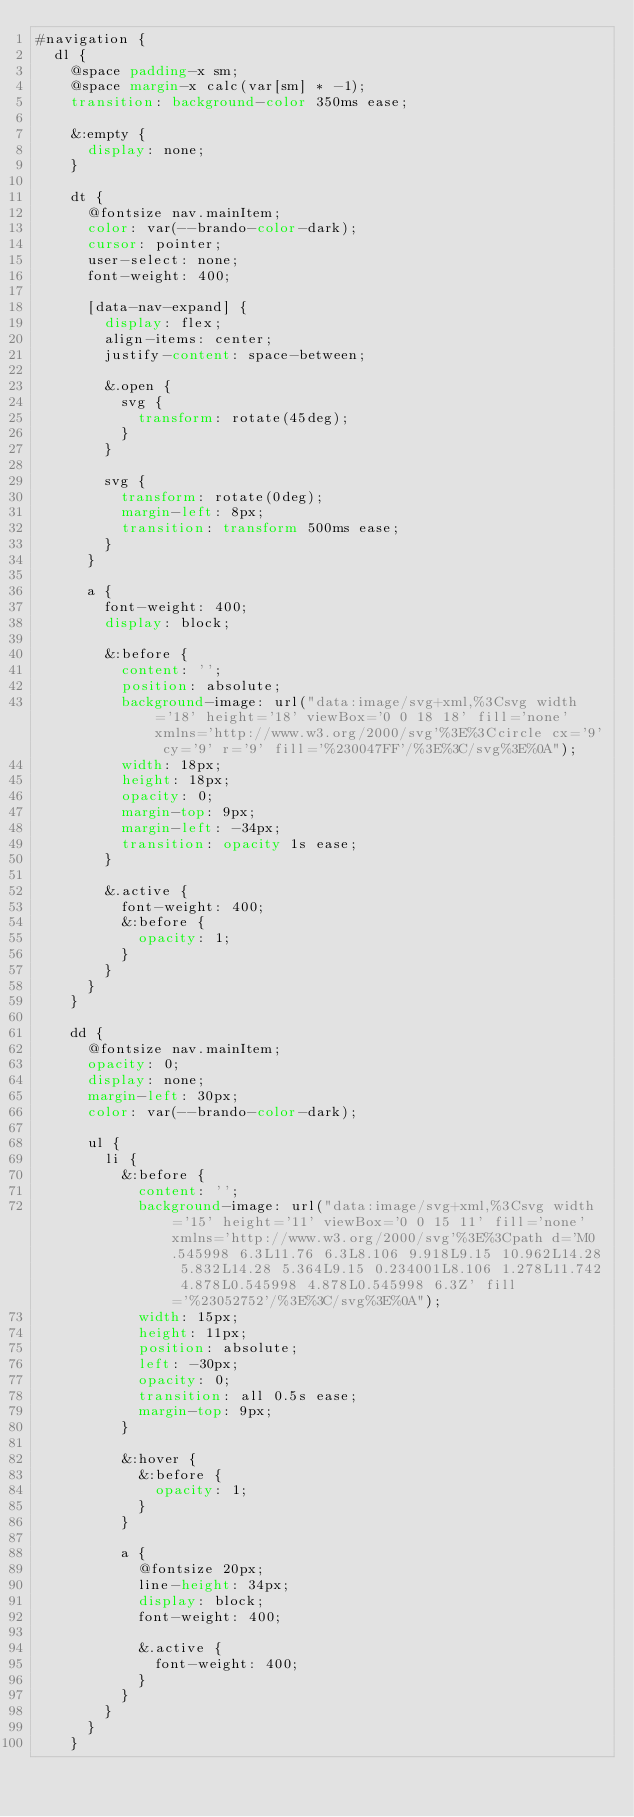Convert code to text. <code><loc_0><loc_0><loc_500><loc_500><_CSS_>#navigation {
  dl {
    @space padding-x sm;
    @space margin-x calc(var[sm] * -1);
    transition: background-color 350ms ease;

    &:empty {
      display: none;
    }

    dt {
      @fontsize nav.mainItem;
      color: var(--brando-color-dark); 
      cursor: pointer;
      user-select: none;
      font-weight: 400;

      [data-nav-expand] {
        display: flex;
        align-items: center;
        justify-content: space-between;

        &.open {
          svg {
            transform: rotate(45deg);
          }
        }

        svg {
          transform: rotate(0deg);
          margin-left: 8px;
          transition: transform 500ms ease;
        }
      }

      a {
        font-weight: 400;
        display: block;

        &:before {
          content: '';
          position: absolute;
          background-image: url("data:image/svg+xml,%3Csvg width='18' height='18' viewBox='0 0 18 18' fill='none' xmlns='http://www.w3.org/2000/svg'%3E%3Ccircle cx='9' cy='9' r='9' fill='%230047FF'/%3E%3C/svg%3E%0A");
          width: 18px;
          height: 18px;
          opacity: 0;
          margin-top: 9px;
          margin-left: -34px;
          transition: opacity 1s ease;
        }

        &.active {
          font-weight: 400;
          &:before {
            opacity: 1;
          }
        }
      }
    }

    dd {
      @fontsize nav.mainItem;
      opacity: 0;
      display: none;
      margin-left: 30px;
      color: var(--brando-color-dark); 

      ul {
        li {
          &:before {
            content: '';
            background-image: url("data:image/svg+xml,%3Csvg width='15' height='11' viewBox='0 0 15 11' fill='none' xmlns='http://www.w3.org/2000/svg'%3E%3Cpath d='M0.545998 6.3L11.76 6.3L8.106 9.918L9.15 10.962L14.28 5.832L14.28 5.364L9.15 0.234001L8.106 1.278L11.742 4.878L0.545998 4.878L0.545998 6.3Z' fill='%23052752'/%3E%3C/svg%3E%0A");
            width: 15px;
            height: 11px;
            position: absolute;
            left: -30px;
            opacity: 0;
            transition: all 0.5s ease;
            margin-top: 9px;
          }

          &:hover {
            &:before {
              opacity: 1;
            }
          }

          a {
            @fontsize 20px;
            line-height: 34px;
            display: block;
            font-weight: 400;

            &.active {
              font-weight: 400;
            }
          }
        }
      }
    }</code> 